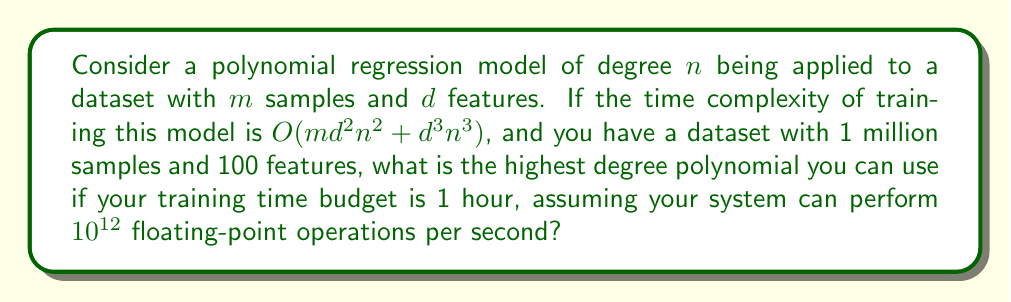Provide a solution to this math problem. Let's approach this step-by-step:

1) First, we need to set up our equation based on the given time complexity:
   
   Time = $c(m d^2 n^2 + d^3 n^3)$, where $c$ is some constant

2) We're given:
   $m = 10^6$ (1 million samples)
   $d = 100$ (100 features)
   Time budget = 1 hour = 3600 seconds
   System capacity = $10^{12}$ operations per second

3) The total number of operations our system can perform in 1 hour is:
   $3600 \times 10^{12} = 3.6 \times 10^{15}$

4) Substituting these values into our equation:

   $3.6 \times 10^{15} = c(10^6 \times 100^2 \times n^2 + 100^3 \times n^3)$

5) Simplifying:

   $3.6 \times 10^{15} = c(10^{10} n^2 + 10^6 n^3)$

6) The constant $c$ represents the actual time taken for each theoretical operation. Let's assume $c = 1$ for simplicity (this will give us an upper bound on $n$).

7) Now we have:

   $3.6 \times 10^{15} = 10^{10} n^2 + 10^6 n^3$

8) Dividing both sides by $10^6$:

   $3.6 \times 10^9 = 10^4 n^2 + n^3$

9) This is a cubic equation in $n$. Solving it exactly would be complex, but we can estimate the solution.

10) Notice that $n^3$ grows much faster than $10^4 n^2$ for large $n$. So for a rough estimate, we can ignore the $10^4 n^2$ term:

    $3.6 \times 10^9 \approx n^3$

11) Taking the cube root of both sides:

    $n \approx \sqrt[3]{3.6 \times 10^9} \approx 1532$

12) This is an overestimate because we ignored the $10^4 n^2$ term. The actual highest value of $n$ that satisfies the equation will be slightly less than this.
Answer: The highest degree polynomial that can be used under the given constraints is approximately 1500. 